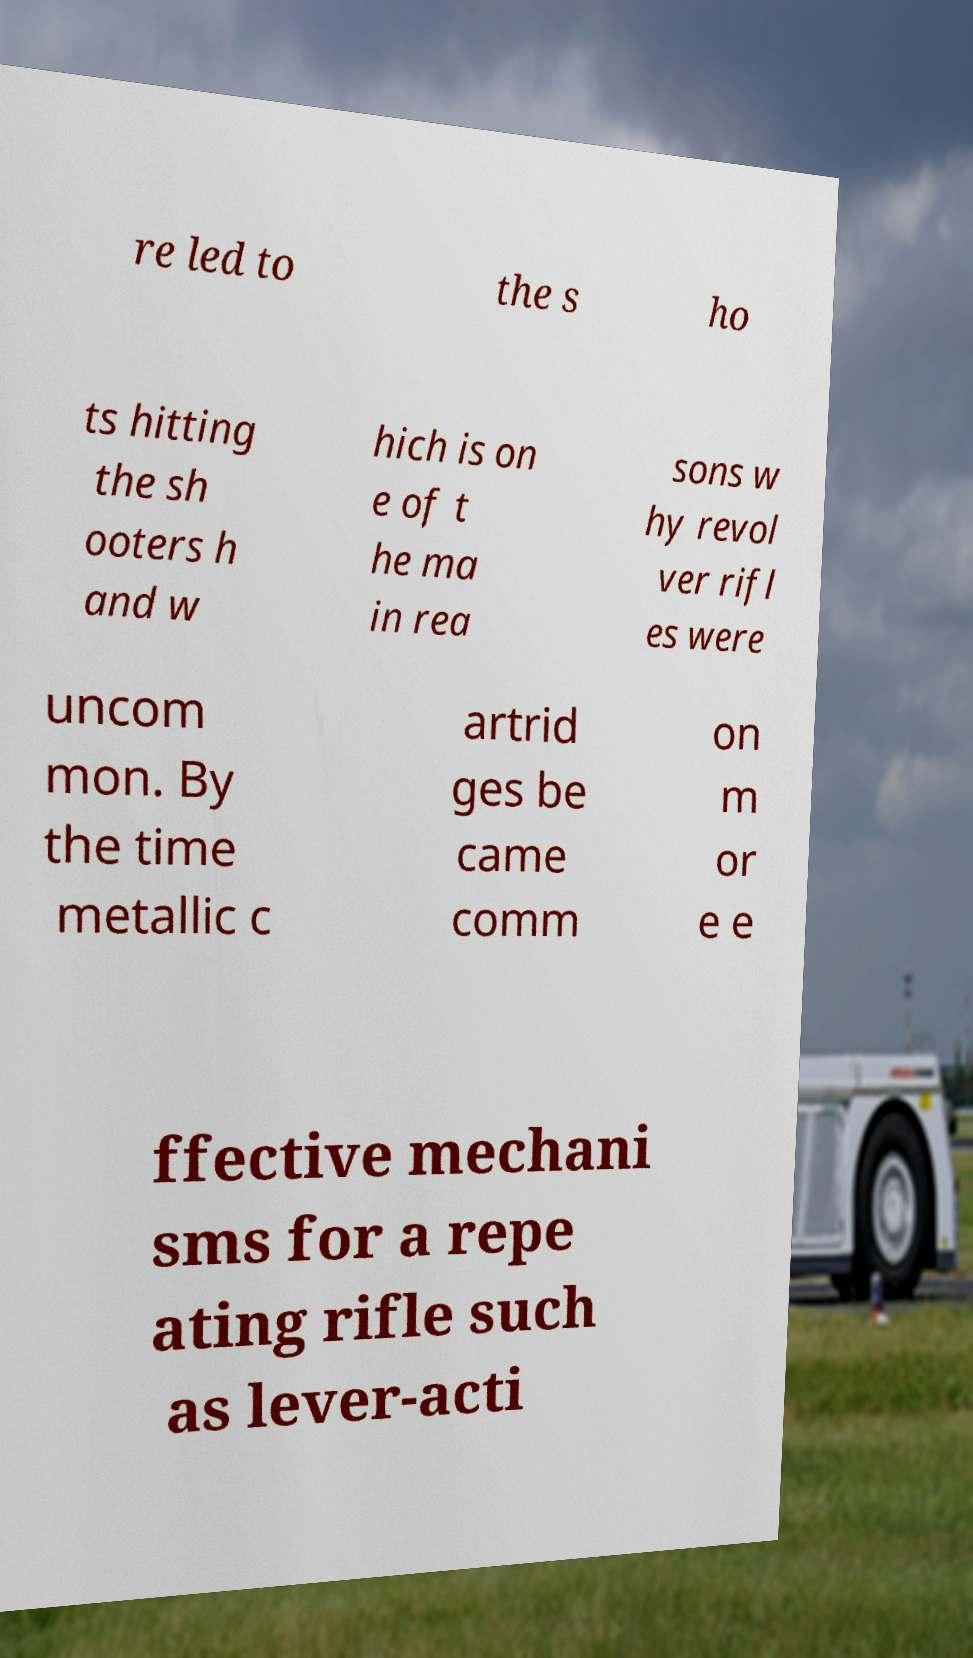Please identify and transcribe the text found in this image. re led to the s ho ts hitting the sh ooters h and w hich is on e of t he ma in rea sons w hy revol ver rifl es were uncom mon. By the time metallic c artrid ges be came comm on m or e e ffective mechani sms for a repe ating rifle such as lever-acti 